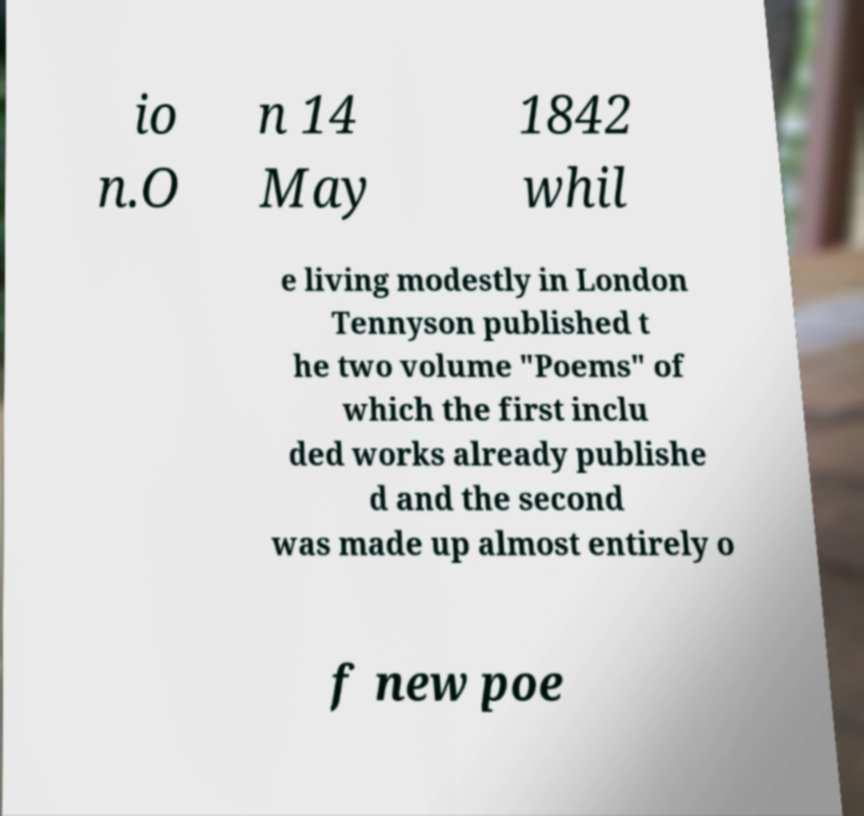Could you extract and type out the text from this image? io n.O n 14 May 1842 whil e living modestly in London Tennyson published t he two volume "Poems" of which the first inclu ded works already publishe d and the second was made up almost entirely o f new poe 